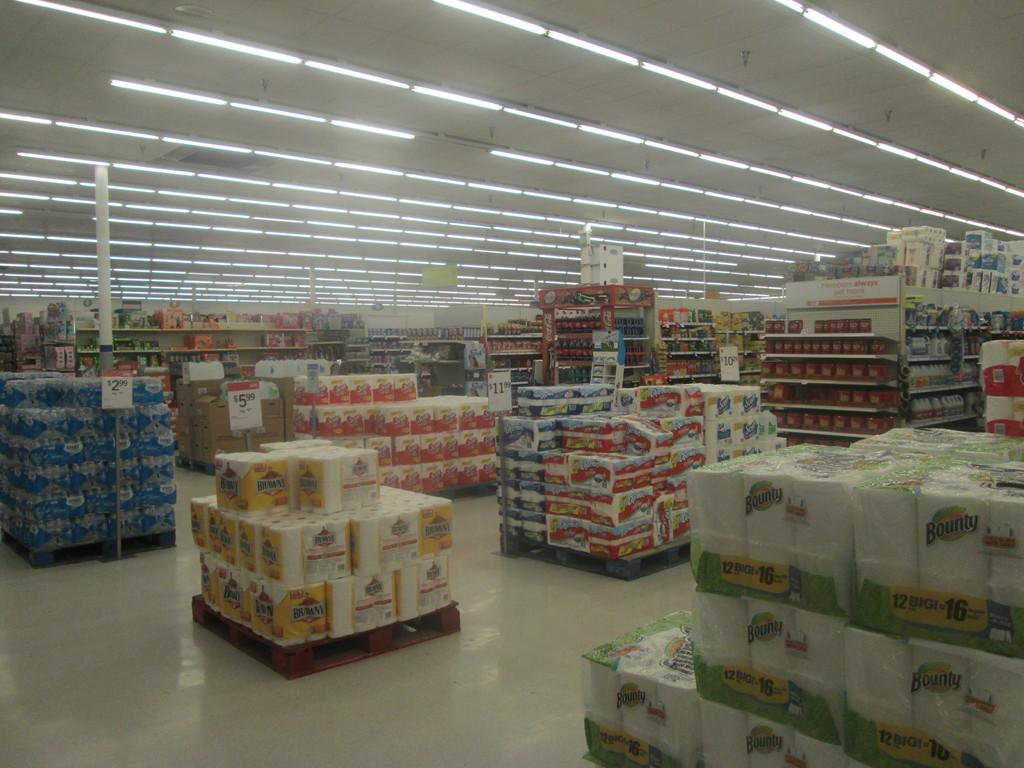<image>
Write a terse but informative summary of the picture. Several floor displays of paper towels by Brawny and Bounty ina super market. 